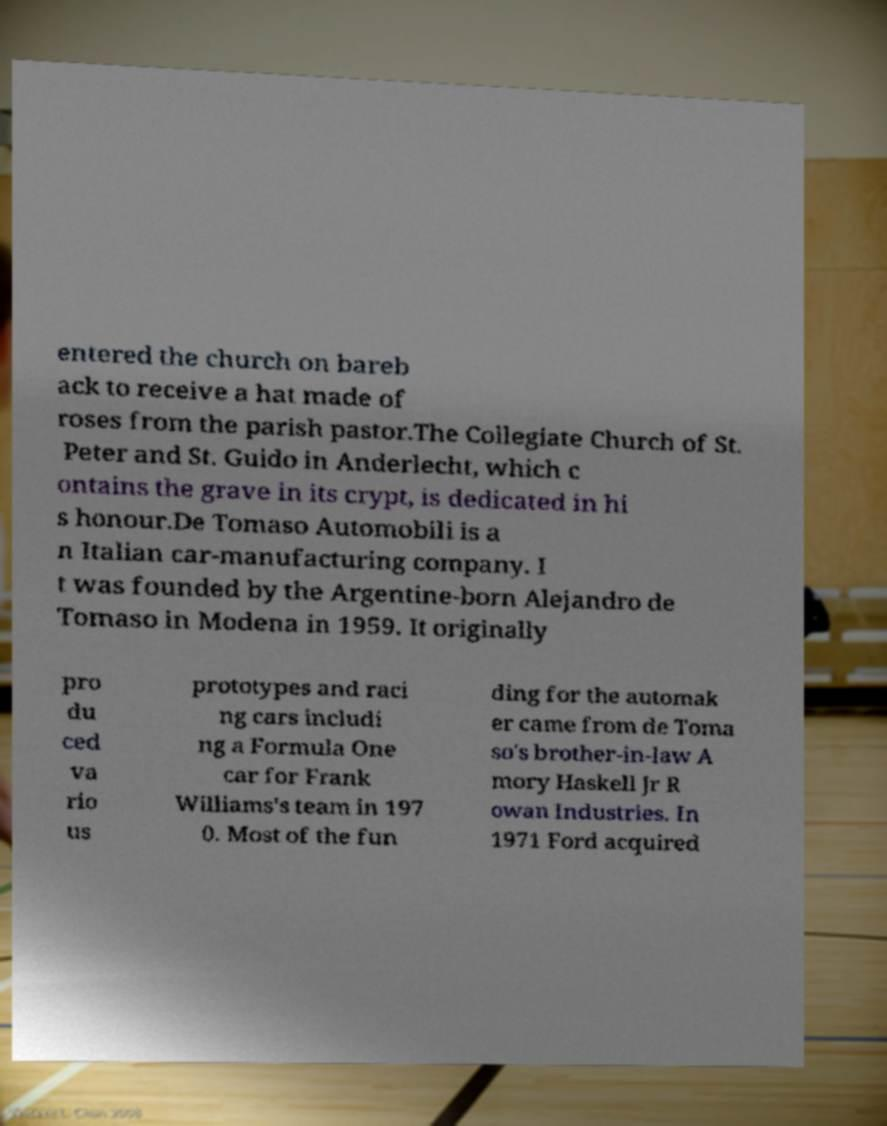Please identify and transcribe the text found in this image. entered the church on bareb ack to receive a hat made of roses from the parish pastor.The Collegiate Church of St. Peter and St. Guido in Anderlecht, which c ontains the grave in its crypt, is dedicated in hi s honour.De Tomaso Automobili is a n Italian car-manufacturing company. I t was founded by the Argentine-born Alejandro de Tomaso in Modena in 1959. It originally pro du ced va rio us prototypes and raci ng cars includi ng a Formula One car for Frank Williams's team in 197 0. Most of the fun ding for the automak er came from de Toma so's brother-in-law A mory Haskell Jr R owan Industries. In 1971 Ford acquired 